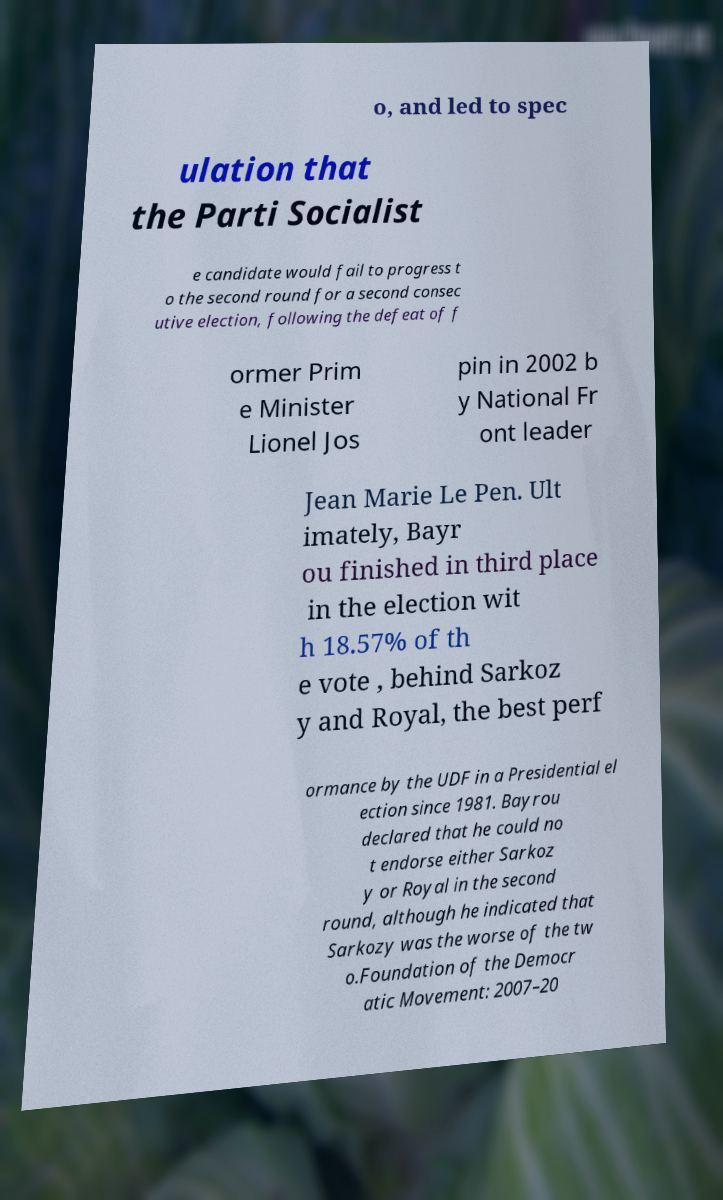For documentation purposes, I need the text within this image transcribed. Could you provide that? o, and led to spec ulation that the Parti Socialist e candidate would fail to progress t o the second round for a second consec utive election, following the defeat of f ormer Prim e Minister Lionel Jos pin in 2002 b y National Fr ont leader Jean Marie Le Pen. Ult imately, Bayr ou finished in third place in the election wit h 18.57% of th e vote , behind Sarkoz y and Royal, the best perf ormance by the UDF in a Presidential el ection since 1981. Bayrou declared that he could no t endorse either Sarkoz y or Royal in the second round, although he indicated that Sarkozy was the worse of the tw o.Foundation of the Democr atic Movement: 2007–20 